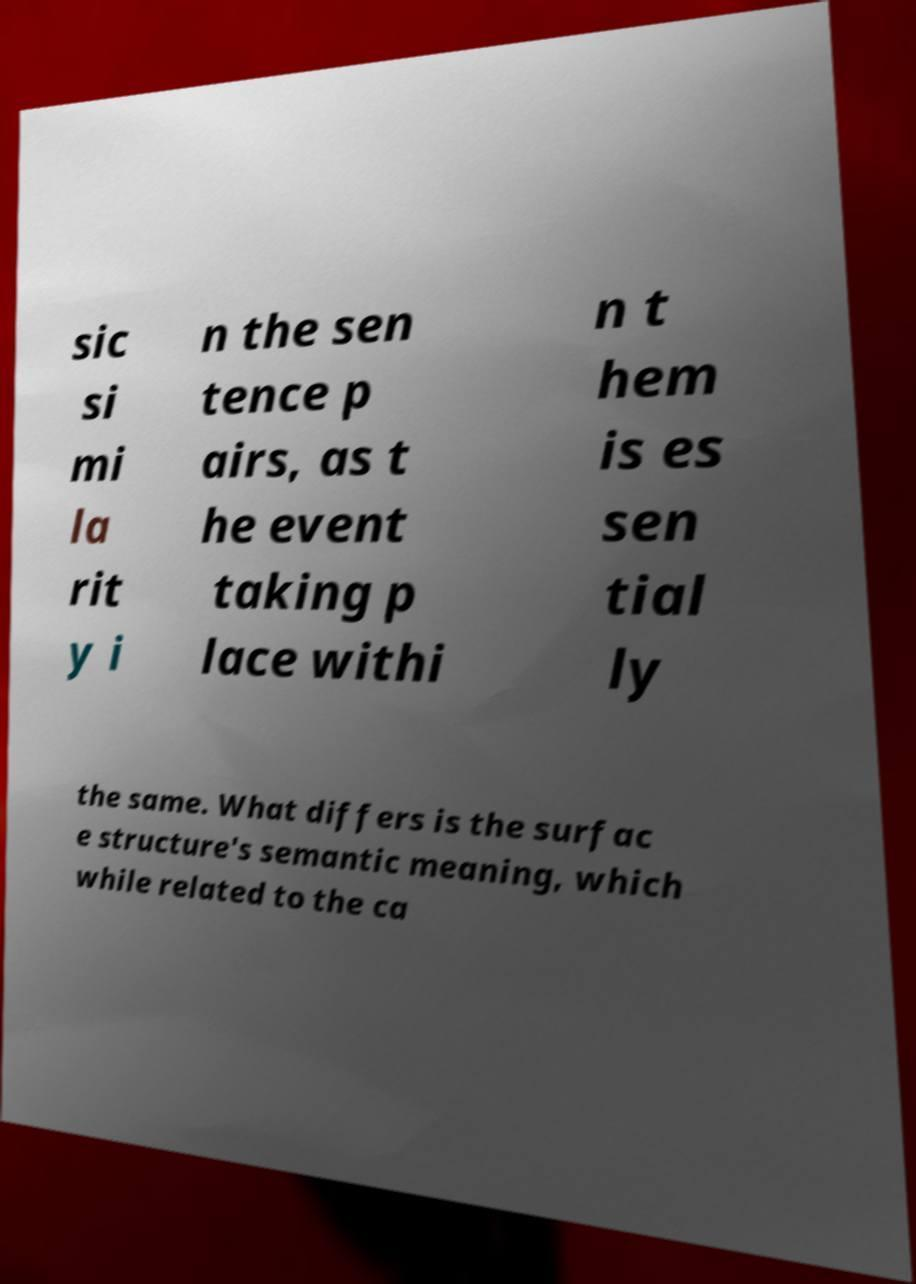Could you extract and type out the text from this image? sic si mi la rit y i n the sen tence p airs, as t he event taking p lace withi n t hem is es sen tial ly the same. What differs is the surfac e structure's semantic meaning, which while related to the ca 